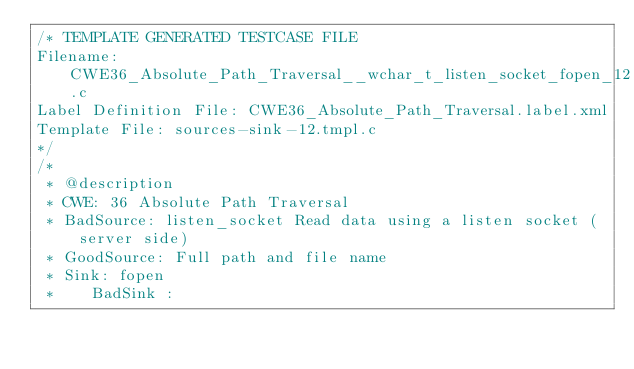Convert code to text. <code><loc_0><loc_0><loc_500><loc_500><_C_>/* TEMPLATE GENERATED TESTCASE FILE
Filename: CWE36_Absolute_Path_Traversal__wchar_t_listen_socket_fopen_12.c
Label Definition File: CWE36_Absolute_Path_Traversal.label.xml
Template File: sources-sink-12.tmpl.c
*/
/*
 * @description
 * CWE: 36 Absolute Path Traversal
 * BadSource: listen_socket Read data using a listen socket (server side)
 * GoodSource: Full path and file name
 * Sink: fopen
 *    BadSink :</code> 